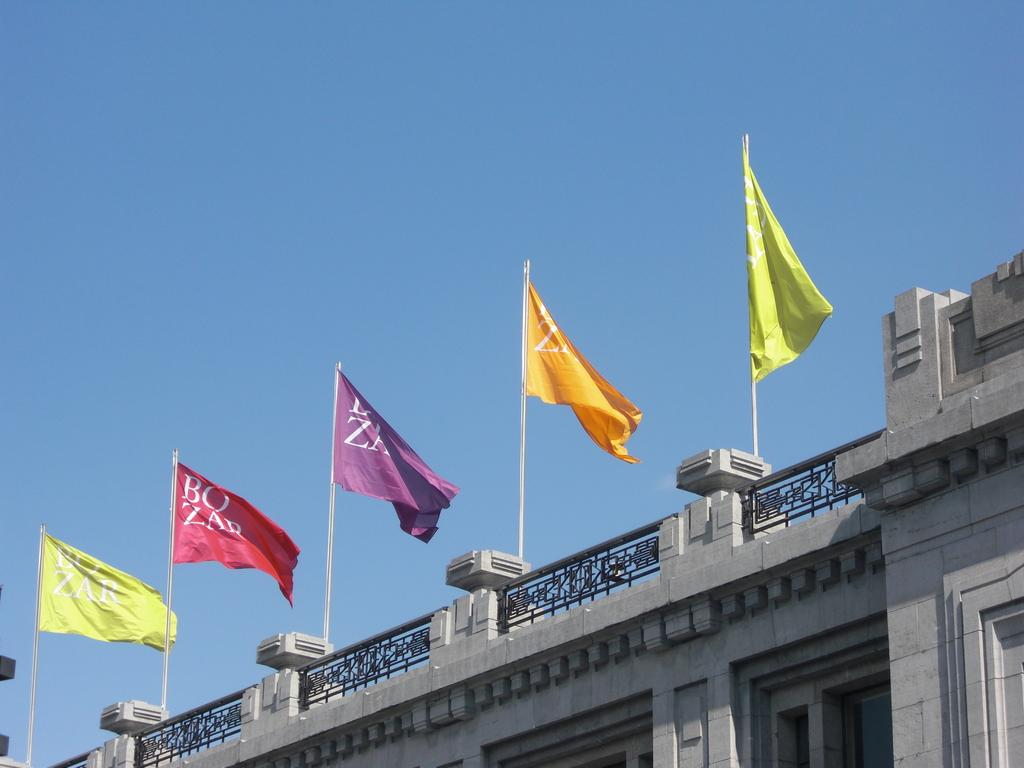What can be seen in the image that represents different countries or organizations? There are flags in different colors in the image. How are the flags displayed in the image? The flags are attached to poles, and the poles are on the floor. Where are the flags located in relation to a structure? The flags are near a building. What feature can be observed on the top of the building? The building has fencing on the top. What is visible in the background of the image? There is a blue sky visible in the background. What title does the squirrel hold in the image? There is no squirrel present in the image, so it cannot hold any title. 